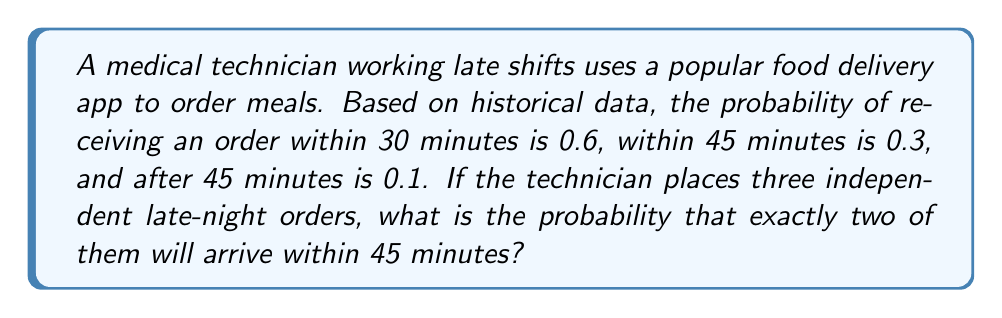Can you answer this question? Let's approach this step-by-step using the binomial probability formula:

1) First, we need to calculate the probability of an order arriving within 45 minutes:
   $P(\text{within 45 min}) = P(\text{within 30 min}) + P(\text{within 30-45 min}) = 0.6 + 0.3 = 0.9$

2) Now, we can use the binomial probability formula:
   $$P(X=k) = \binom{n}{k} p^k (1-p)^{n-k}$$
   
   Where:
   $n$ is the number of trials (orders) = 3
   $k$ is the number of successes (orders arriving within 45 minutes) = 2
   $p$ is the probability of success on each trial = 0.9
   
3) Let's substitute these values:
   $$P(X=2) = \binom{3}{2} (0.9)^2 (1-0.9)^{3-2}$$

4) Calculate the binomial coefficient:
   $$\binom{3}{2} = \frac{3!}{2!(3-2)!} = \frac{3 \cdot 2 \cdot 1}{(2 \cdot 1)(1)} = 3$$

5) Now we can compute:
   $$P(X=2) = 3 \cdot (0.9)^2 \cdot (0.1)^1 = 3 \cdot 0.81 \cdot 0.1 = 0.243$$

Therefore, the probability that exactly two out of three orders will arrive within 45 minutes is 0.243 or 24.3%.
Answer: 0.243 or 24.3% 